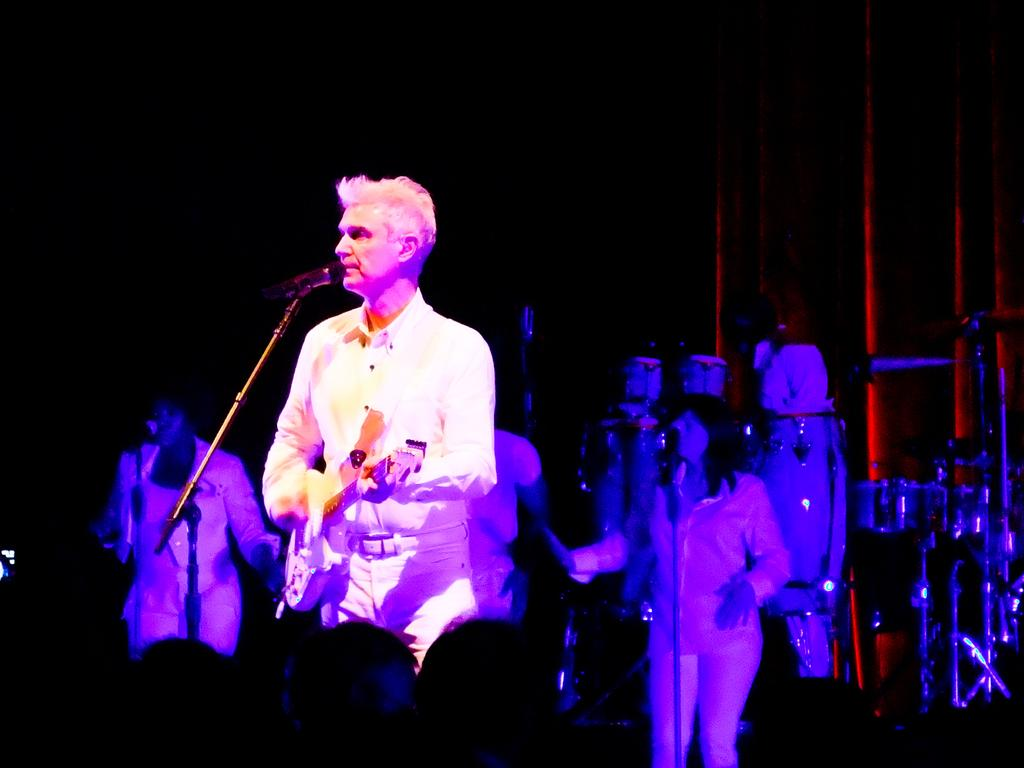What are the persons in the image doing? The persons in the image are standing and holding guitars. What object is in front of the persons? There is a microphone in front of the persons. What can be seen in the background of the image? There is a wall and musical instruments in the background of the image. What type of brain activity can be observed in the persons while they are holding the guitars? There is no information about brain activity in the image, as it only shows the persons holding guitars and standing near a microphone. Is there a garden visible in the image? No, there is no garden present in the image. 